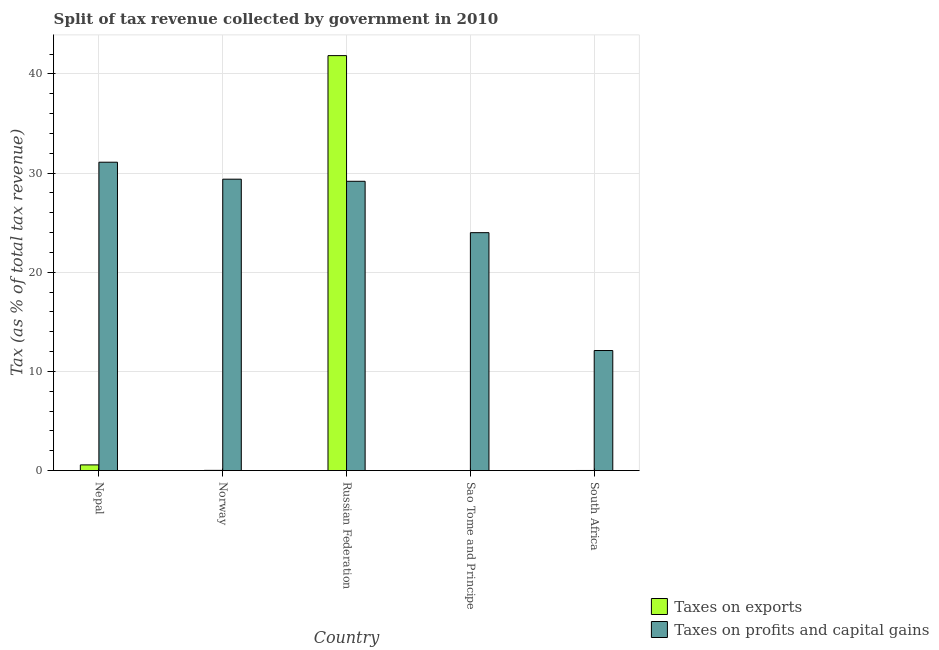How many different coloured bars are there?
Keep it short and to the point. 2. Are the number of bars per tick equal to the number of legend labels?
Provide a succinct answer. Yes. Are the number of bars on each tick of the X-axis equal?
Offer a very short reply. Yes. What is the label of the 4th group of bars from the left?
Provide a short and direct response. Sao Tome and Principe. In how many cases, is the number of bars for a given country not equal to the number of legend labels?
Give a very brief answer. 0. What is the percentage of revenue obtained from taxes on profits and capital gains in Norway?
Keep it short and to the point. 29.38. Across all countries, what is the maximum percentage of revenue obtained from taxes on exports?
Your answer should be compact. 41.84. Across all countries, what is the minimum percentage of revenue obtained from taxes on profits and capital gains?
Provide a succinct answer. 12.1. In which country was the percentage of revenue obtained from taxes on exports maximum?
Your answer should be compact. Russian Federation. In which country was the percentage of revenue obtained from taxes on profits and capital gains minimum?
Make the answer very short. South Africa. What is the total percentage of revenue obtained from taxes on profits and capital gains in the graph?
Make the answer very short. 125.73. What is the difference between the percentage of revenue obtained from taxes on exports in Russian Federation and that in South Africa?
Offer a very short reply. 41.83. What is the difference between the percentage of revenue obtained from taxes on profits and capital gains in Russian Federation and the percentage of revenue obtained from taxes on exports in South Africa?
Provide a succinct answer. 29.16. What is the average percentage of revenue obtained from taxes on profits and capital gains per country?
Make the answer very short. 25.15. What is the difference between the percentage of revenue obtained from taxes on profits and capital gains and percentage of revenue obtained from taxes on exports in South Africa?
Provide a short and direct response. 12.09. In how many countries, is the percentage of revenue obtained from taxes on exports greater than 14 %?
Give a very brief answer. 1. What is the ratio of the percentage of revenue obtained from taxes on exports in Sao Tome and Principe to that in South Africa?
Offer a very short reply. 0.09. Is the percentage of revenue obtained from taxes on profits and capital gains in Nepal less than that in Russian Federation?
Your response must be concise. No. Is the difference between the percentage of revenue obtained from taxes on profits and capital gains in Nepal and Russian Federation greater than the difference between the percentage of revenue obtained from taxes on exports in Nepal and Russian Federation?
Your answer should be very brief. Yes. What is the difference between the highest and the second highest percentage of revenue obtained from taxes on profits and capital gains?
Make the answer very short. 1.71. What is the difference between the highest and the lowest percentage of revenue obtained from taxes on exports?
Make the answer very short. 41.84. In how many countries, is the percentage of revenue obtained from taxes on exports greater than the average percentage of revenue obtained from taxes on exports taken over all countries?
Make the answer very short. 1. What does the 1st bar from the left in Norway represents?
Your answer should be very brief. Taxes on exports. What does the 1st bar from the right in Sao Tome and Principe represents?
Provide a succinct answer. Taxes on profits and capital gains. Are all the bars in the graph horizontal?
Your response must be concise. No. How many countries are there in the graph?
Make the answer very short. 5. How many legend labels are there?
Keep it short and to the point. 2. What is the title of the graph?
Provide a short and direct response. Split of tax revenue collected by government in 2010. Does "Health Care" appear as one of the legend labels in the graph?
Your response must be concise. No. What is the label or title of the Y-axis?
Keep it short and to the point. Tax (as % of total tax revenue). What is the Tax (as % of total tax revenue) of Taxes on exports in Nepal?
Offer a terse response. 0.57. What is the Tax (as % of total tax revenue) in Taxes on profits and capital gains in Nepal?
Offer a very short reply. 31.09. What is the Tax (as % of total tax revenue) of Taxes on exports in Norway?
Your answer should be compact. 0.02. What is the Tax (as % of total tax revenue) of Taxes on profits and capital gains in Norway?
Keep it short and to the point. 29.38. What is the Tax (as % of total tax revenue) of Taxes on exports in Russian Federation?
Your response must be concise. 41.84. What is the Tax (as % of total tax revenue) of Taxes on profits and capital gains in Russian Federation?
Provide a short and direct response. 29.17. What is the Tax (as % of total tax revenue) in Taxes on exports in Sao Tome and Principe?
Provide a short and direct response. 0. What is the Tax (as % of total tax revenue) of Taxes on profits and capital gains in Sao Tome and Principe?
Keep it short and to the point. 23.99. What is the Tax (as % of total tax revenue) of Taxes on exports in South Africa?
Your answer should be very brief. 0.01. What is the Tax (as % of total tax revenue) of Taxes on profits and capital gains in South Africa?
Ensure brevity in your answer.  12.1. Across all countries, what is the maximum Tax (as % of total tax revenue) in Taxes on exports?
Offer a terse response. 41.84. Across all countries, what is the maximum Tax (as % of total tax revenue) of Taxes on profits and capital gains?
Offer a very short reply. 31.09. Across all countries, what is the minimum Tax (as % of total tax revenue) of Taxes on exports?
Ensure brevity in your answer.  0. Across all countries, what is the minimum Tax (as % of total tax revenue) in Taxes on profits and capital gains?
Give a very brief answer. 12.1. What is the total Tax (as % of total tax revenue) of Taxes on exports in the graph?
Your answer should be very brief. 42.44. What is the total Tax (as % of total tax revenue) in Taxes on profits and capital gains in the graph?
Your answer should be compact. 125.73. What is the difference between the Tax (as % of total tax revenue) of Taxes on exports in Nepal and that in Norway?
Keep it short and to the point. 0.55. What is the difference between the Tax (as % of total tax revenue) of Taxes on profits and capital gains in Nepal and that in Norway?
Give a very brief answer. 1.71. What is the difference between the Tax (as % of total tax revenue) in Taxes on exports in Nepal and that in Russian Federation?
Your response must be concise. -41.26. What is the difference between the Tax (as % of total tax revenue) of Taxes on profits and capital gains in Nepal and that in Russian Federation?
Your answer should be compact. 1.92. What is the difference between the Tax (as % of total tax revenue) in Taxes on exports in Nepal and that in Sao Tome and Principe?
Provide a short and direct response. 0.57. What is the difference between the Tax (as % of total tax revenue) in Taxes on profits and capital gains in Nepal and that in Sao Tome and Principe?
Give a very brief answer. 7.1. What is the difference between the Tax (as % of total tax revenue) of Taxes on exports in Nepal and that in South Africa?
Your answer should be very brief. 0.56. What is the difference between the Tax (as % of total tax revenue) in Taxes on profits and capital gains in Nepal and that in South Africa?
Ensure brevity in your answer.  18.99. What is the difference between the Tax (as % of total tax revenue) of Taxes on exports in Norway and that in Russian Federation?
Offer a very short reply. -41.82. What is the difference between the Tax (as % of total tax revenue) of Taxes on profits and capital gains in Norway and that in Russian Federation?
Provide a succinct answer. 0.21. What is the difference between the Tax (as % of total tax revenue) of Taxes on exports in Norway and that in Sao Tome and Principe?
Ensure brevity in your answer.  0.02. What is the difference between the Tax (as % of total tax revenue) in Taxes on profits and capital gains in Norway and that in Sao Tome and Principe?
Your response must be concise. 5.39. What is the difference between the Tax (as % of total tax revenue) of Taxes on exports in Norway and that in South Africa?
Your response must be concise. 0.01. What is the difference between the Tax (as % of total tax revenue) in Taxes on profits and capital gains in Norway and that in South Africa?
Provide a short and direct response. 17.27. What is the difference between the Tax (as % of total tax revenue) of Taxes on exports in Russian Federation and that in Sao Tome and Principe?
Keep it short and to the point. 41.84. What is the difference between the Tax (as % of total tax revenue) in Taxes on profits and capital gains in Russian Federation and that in Sao Tome and Principe?
Your response must be concise. 5.18. What is the difference between the Tax (as % of total tax revenue) of Taxes on exports in Russian Federation and that in South Africa?
Provide a succinct answer. 41.83. What is the difference between the Tax (as % of total tax revenue) in Taxes on profits and capital gains in Russian Federation and that in South Africa?
Make the answer very short. 17.06. What is the difference between the Tax (as % of total tax revenue) of Taxes on exports in Sao Tome and Principe and that in South Africa?
Make the answer very short. -0.01. What is the difference between the Tax (as % of total tax revenue) of Taxes on profits and capital gains in Sao Tome and Principe and that in South Africa?
Provide a short and direct response. 11.88. What is the difference between the Tax (as % of total tax revenue) in Taxes on exports in Nepal and the Tax (as % of total tax revenue) in Taxes on profits and capital gains in Norway?
Your response must be concise. -28.81. What is the difference between the Tax (as % of total tax revenue) of Taxes on exports in Nepal and the Tax (as % of total tax revenue) of Taxes on profits and capital gains in Russian Federation?
Give a very brief answer. -28.59. What is the difference between the Tax (as % of total tax revenue) in Taxes on exports in Nepal and the Tax (as % of total tax revenue) in Taxes on profits and capital gains in Sao Tome and Principe?
Your response must be concise. -23.41. What is the difference between the Tax (as % of total tax revenue) of Taxes on exports in Nepal and the Tax (as % of total tax revenue) of Taxes on profits and capital gains in South Africa?
Your response must be concise. -11.53. What is the difference between the Tax (as % of total tax revenue) in Taxes on exports in Norway and the Tax (as % of total tax revenue) in Taxes on profits and capital gains in Russian Federation?
Offer a terse response. -29.15. What is the difference between the Tax (as % of total tax revenue) of Taxes on exports in Norway and the Tax (as % of total tax revenue) of Taxes on profits and capital gains in Sao Tome and Principe?
Offer a very short reply. -23.96. What is the difference between the Tax (as % of total tax revenue) in Taxes on exports in Norway and the Tax (as % of total tax revenue) in Taxes on profits and capital gains in South Africa?
Your response must be concise. -12.08. What is the difference between the Tax (as % of total tax revenue) of Taxes on exports in Russian Federation and the Tax (as % of total tax revenue) of Taxes on profits and capital gains in Sao Tome and Principe?
Give a very brief answer. 17.85. What is the difference between the Tax (as % of total tax revenue) of Taxes on exports in Russian Federation and the Tax (as % of total tax revenue) of Taxes on profits and capital gains in South Africa?
Provide a short and direct response. 29.73. What is the difference between the Tax (as % of total tax revenue) of Taxes on exports in Sao Tome and Principe and the Tax (as % of total tax revenue) of Taxes on profits and capital gains in South Africa?
Provide a short and direct response. -12.1. What is the average Tax (as % of total tax revenue) in Taxes on exports per country?
Provide a short and direct response. 8.49. What is the average Tax (as % of total tax revenue) in Taxes on profits and capital gains per country?
Give a very brief answer. 25.15. What is the difference between the Tax (as % of total tax revenue) of Taxes on exports and Tax (as % of total tax revenue) of Taxes on profits and capital gains in Nepal?
Provide a short and direct response. -30.52. What is the difference between the Tax (as % of total tax revenue) in Taxes on exports and Tax (as % of total tax revenue) in Taxes on profits and capital gains in Norway?
Give a very brief answer. -29.36. What is the difference between the Tax (as % of total tax revenue) of Taxes on exports and Tax (as % of total tax revenue) of Taxes on profits and capital gains in Russian Federation?
Keep it short and to the point. 12.67. What is the difference between the Tax (as % of total tax revenue) of Taxes on exports and Tax (as % of total tax revenue) of Taxes on profits and capital gains in Sao Tome and Principe?
Ensure brevity in your answer.  -23.99. What is the difference between the Tax (as % of total tax revenue) in Taxes on exports and Tax (as % of total tax revenue) in Taxes on profits and capital gains in South Africa?
Your answer should be compact. -12.09. What is the ratio of the Tax (as % of total tax revenue) of Taxes on exports in Nepal to that in Norway?
Keep it short and to the point. 26.46. What is the ratio of the Tax (as % of total tax revenue) of Taxes on profits and capital gains in Nepal to that in Norway?
Offer a terse response. 1.06. What is the ratio of the Tax (as % of total tax revenue) in Taxes on exports in Nepal to that in Russian Federation?
Your answer should be compact. 0.01. What is the ratio of the Tax (as % of total tax revenue) in Taxes on profits and capital gains in Nepal to that in Russian Federation?
Make the answer very short. 1.07. What is the ratio of the Tax (as % of total tax revenue) of Taxes on exports in Nepal to that in Sao Tome and Principe?
Offer a terse response. 651.05. What is the ratio of the Tax (as % of total tax revenue) of Taxes on profits and capital gains in Nepal to that in Sao Tome and Principe?
Your response must be concise. 1.3. What is the ratio of the Tax (as % of total tax revenue) in Taxes on exports in Nepal to that in South Africa?
Your answer should be compact. 56.01. What is the ratio of the Tax (as % of total tax revenue) in Taxes on profits and capital gains in Nepal to that in South Africa?
Ensure brevity in your answer.  2.57. What is the ratio of the Tax (as % of total tax revenue) of Taxes on exports in Norway to that in Russian Federation?
Provide a succinct answer. 0. What is the ratio of the Tax (as % of total tax revenue) of Taxes on profits and capital gains in Norway to that in Russian Federation?
Offer a very short reply. 1.01. What is the ratio of the Tax (as % of total tax revenue) in Taxes on exports in Norway to that in Sao Tome and Principe?
Offer a very short reply. 24.61. What is the ratio of the Tax (as % of total tax revenue) in Taxes on profits and capital gains in Norway to that in Sao Tome and Principe?
Offer a very short reply. 1.22. What is the ratio of the Tax (as % of total tax revenue) in Taxes on exports in Norway to that in South Africa?
Keep it short and to the point. 2.12. What is the ratio of the Tax (as % of total tax revenue) in Taxes on profits and capital gains in Norway to that in South Africa?
Offer a very short reply. 2.43. What is the ratio of the Tax (as % of total tax revenue) of Taxes on exports in Russian Federation to that in Sao Tome and Principe?
Your answer should be compact. 4.75e+04. What is the ratio of the Tax (as % of total tax revenue) in Taxes on profits and capital gains in Russian Federation to that in Sao Tome and Principe?
Offer a terse response. 1.22. What is the ratio of the Tax (as % of total tax revenue) in Taxes on exports in Russian Federation to that in South Africa?
Provide a short and direct response. 4090.06. What is the ratio of the Tax (as % of total tax revenue) in Taxes on profits and capital gains in Russian Federation to that in South Africa?
Provide a short and direct response. 2.41. What is the ratio of the Tax (as % of total tax revenue) of Taxes on exports in Sao Tome and Principe to that in South Africa?
Your answer should be compact. 0.09. What is the ratio of the Tax (as % of total tax revenue) in Taxes on profits and capital gains in Sao Tome and Principe to that in South Africa?
Your response must be concise. 1.98. What is the difference between the highest and the second highest Tax (as % of total tax revenue) in Taxes on exports?
Ensure brevity in your answer.  41.26. What is the difference between the highest and the second highest Tax (as % of total tax revenue) in Taxes on profits and capital gains?
Give a very brief answer. 1.71. What is the difference between the highest and the lowest Tax (as % of total tax revenue) in Taxes on exports?
Make the answer very short. 41.84. What is the difference between the highest and the lowest Tax (as % of total tax revenue) of Taxes on profits and capital gains?
Your response must be concise. 18.99. 